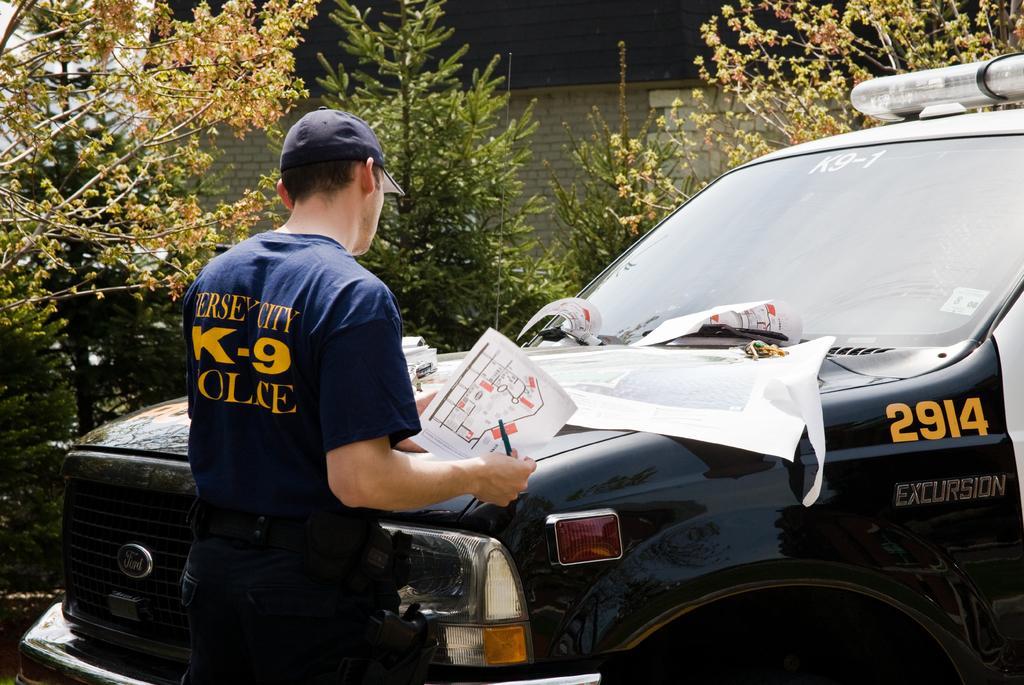Could you give a brief overview of what you see in this image? In this image we can see this person wearing blue T-shirt and cap is holding a pen and paper and standing near the vehicle where a few more papers are kept here. In the background, we can see trees and brick house. 